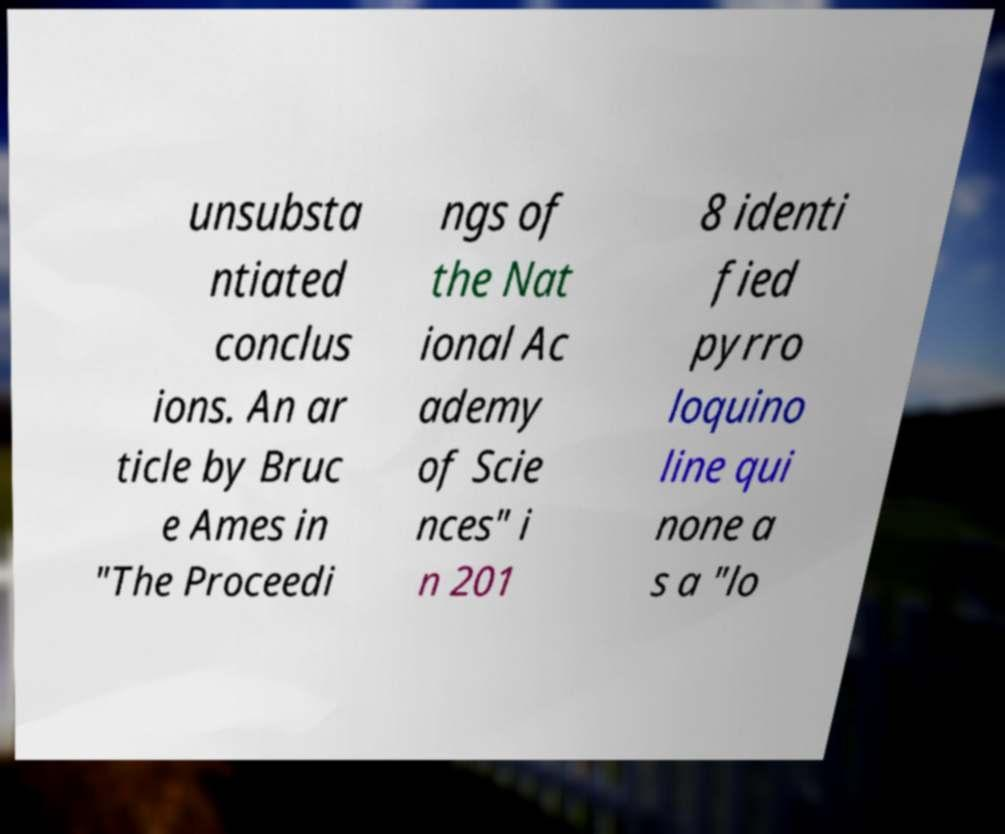I need the written content from this picture converted into text. Can you do that? unsubsta ntiated conclus ions. An ar ticle by Bruc e Ames in "The Proceedi ngs of the Nat ional Ac ademy of Scie nces" i n 201 8 identi fied pyrro loquino line qui none a s a "lo 